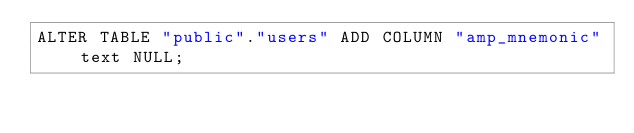<code> <loc_0><loc_0><loc_500><loc_500><_SQL_>ALTER TABLE "public"."users" ADD COLUMN "amp_mnemonic" text NULL;
</code> 